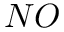<formula> <loc_0><loc_0><loc_500><loc_500>N O</formula> 